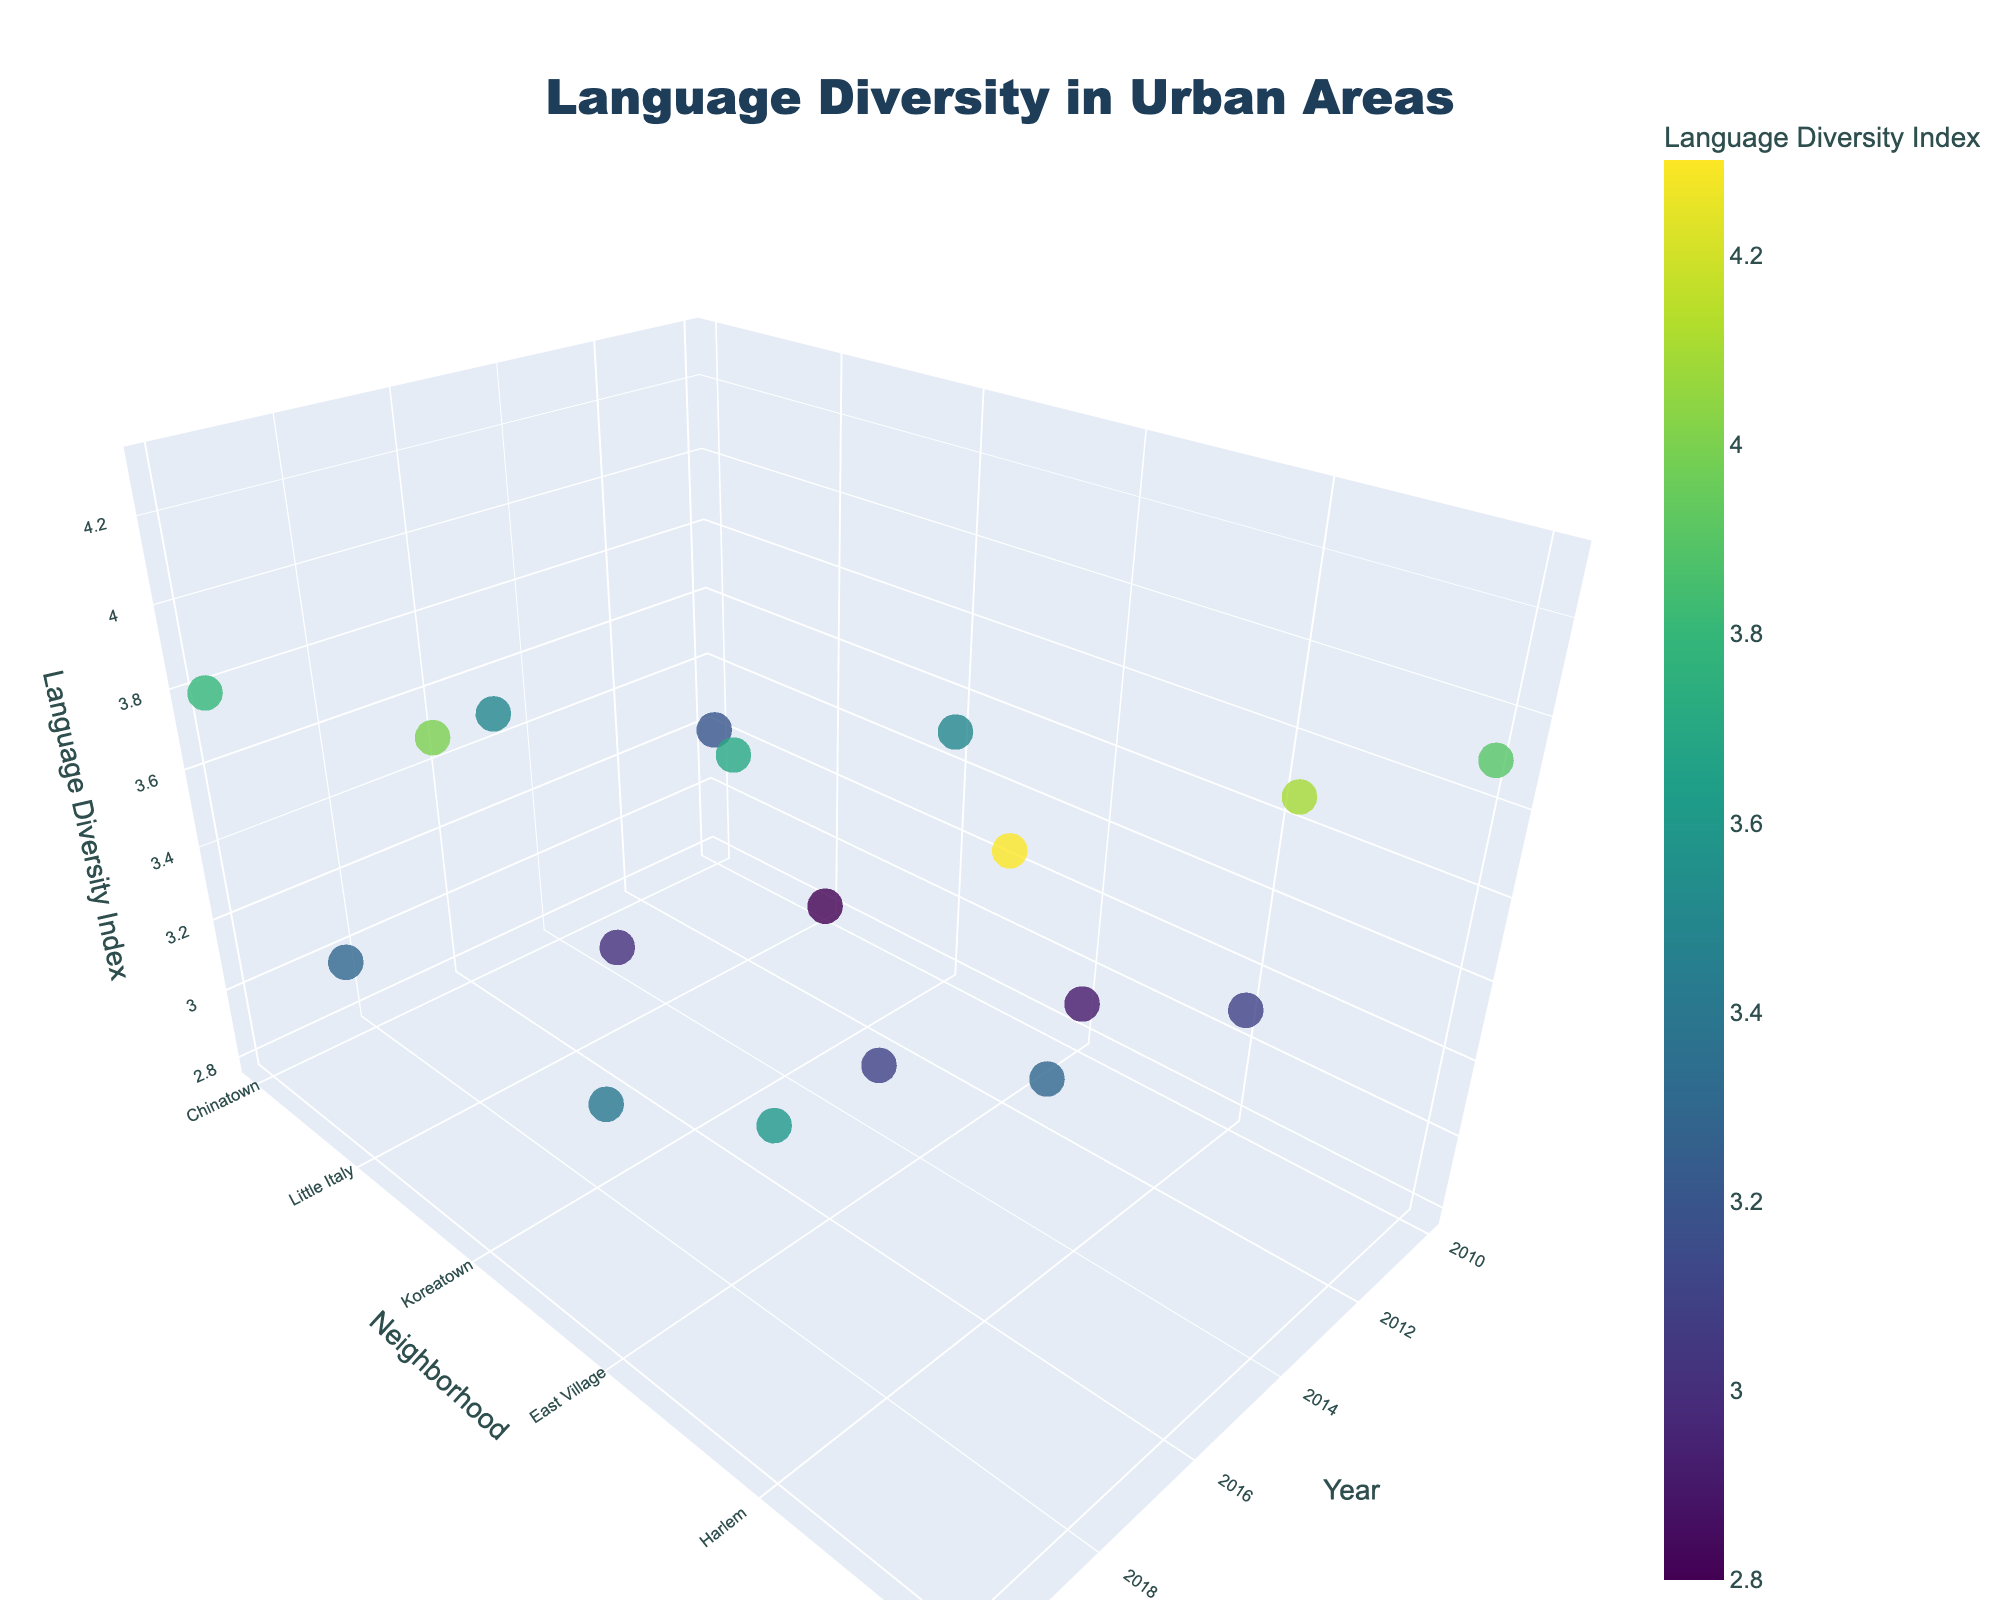What is the title of the figure? The title of the figure can be found at the top of the plot, where it is usually displayed prominently.
Answer: Language Diversity in Urban Areas What do the colors of the markers represent? The colors on the markers can be interpreted by looking at the color bar legend on the right side of the plot, which indicates that colors represent the Language Diversity Index values.
Answer: Language Diversity Index values How does the Language Diversity Index in Chinatown change from 2010 to 2020? To answer this, observe the z-axis values for the Chinatown neighborhood over the years 2010, 2015, and 2020. For Chinatown, the values are 3.2 (2010), 3.5 (2015), and 3.8 (2020). Thus, the Language Diversity Index increases over time.
Answer: It increases Which neighborhood had the highest Language Diversity Index in 2020? By examining the z-axis values for each neighborhood in 2020, you can see that Jackson Heights has the highest value at 4.3.
Answer: Jackson Heights Between what range do the Language Diversity Index values vary in the figure? By looking at the color bar legend, as well as the markers' positions on the z-axis, the values range approximately from 2.8 to 4.3.
Answer: 2.8 to 4.3 What's the average increase in the Language Diversity Index for all neighborhoods from 2010 to 2020? Calculate the increase for each neighborhood and then average them: Chinatown (3.8 - 3.2 = 0.6), Little Italy (3.3 - 2.8 = 0.5), Koreatown (4.0 - 3.5 = 0.5), East Village (3.4 - 2.9 = 0.5), Harlem (3.6 - 3.1 = 0.5), Jackson Heights (4.3 - 3.9 = 0.4). The average increase is (0.6+0.5+0.5+0.5+0.5+0.4)/6 = 0.5.
Answer: 0.5 Which proficiency level generally shows higher Language Diversity Index values? Using the hover text information and the z-axis, it can be observed that Advanced proficiency levels (hover texts) are generally associated with higher Language Diversity Index values.
Answer: Advanced How does the neighborhood diversity index at intermediate proficiency change from Harlem between 2010 and 2020? For Harlem, observe the z-axis values at intermediate proficiency levels in 2010 (3.1), 2015 (3.3), and 2020 (3.6). It shows an increase over these years.
Answer: It increases Comparing Koreatown and East Village at beginner proficiency over the years, which has seen a greater change in Language Diversity Index from 2010 to 2020? Calculate the changes for each neighborhood: Koreatown (4.0 - 3.5 = 0.5) and East Village (3.4 - 2.9 = 0.5). Both neighborhoods have seen the same change of 0.5 in their index.
Answer: Both are the same What's the sum of the Language Diversity Index for Little Italy across all years? Add the z-axis values for Little Italy in each year: 2.8 (2010) + 3.0 (2015) + 3.3 (2020) = 9.1.
Answer: 9.1 